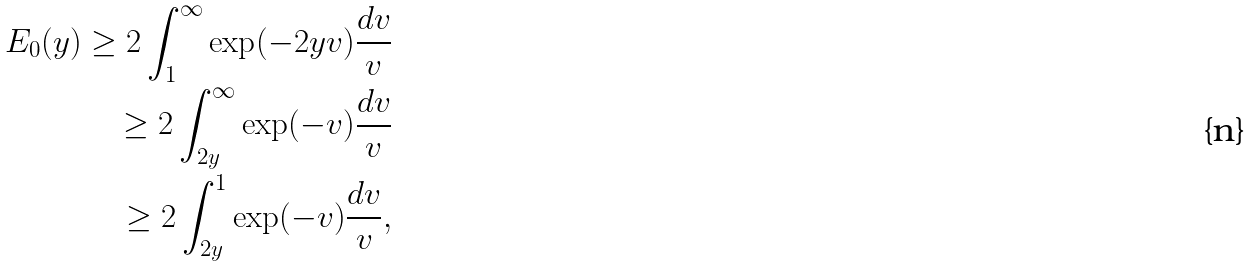<formula> <loc_0><loc_0><loc_500><loc_500>E _ { 0 } ( y ) \geq 2 \int _ { 1 } ^ { \infty } \exp ( - 2 y v ) \frac { d v } { v } \\ \geq 2 \int _ { 2 y } ^ { \infty } \exp ( - v ) \frac { d v } { v } \\ \geq 2 \int _ { 2 y } ^ { 1 } \exp ( - v ) \frac { d v } { v } ,</formula> 